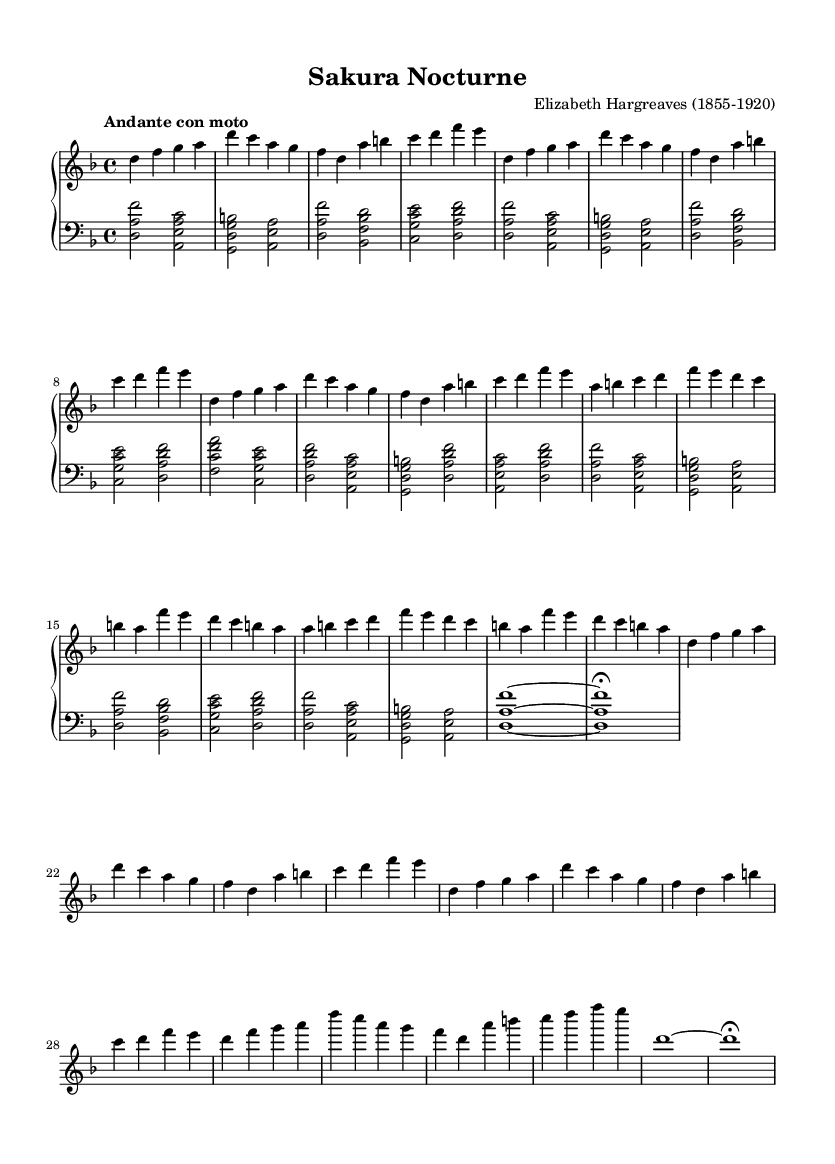What is the key signature of this music? The key signature is D minor, indicated by one flat (B flat) in the key signature line at the beginning of the staff. This is derived from the "global" context in the provided code.
Answer: D minor What is the time signature of this piece? The time signature is 4/4, shown at the beginning of the music. This indicates that there are four beats in each measure, and the quarter note gets one beat.
Answer: 4/4 What is the tempo marking for this piece? The tempo marking is "Andante con moto," which implies a moderately slow tempo with some movement. This is also detailed in the "global" context of the code.
Answer: Andante con moto What is the highest note in the right hand during section A? The highest note in the right hand during section A is A, found in the first measure of section A where the right hand plays A above the staff.
Answer: A How many measures are in the piece? The piece consists of 27 measures total; this can be determined by counting the measures in each section as defined in the right-hand and left-hand parts in the code.
Answer: 27 What is the chord of the left hand in the introduction first measure? The chord in the left hand during the first measure of the introduction is a D major chord (D, A, F#), which is identified by looking at the notes indicated in that measure.
Answer: D major How many sections are there in this composition? The composition has four sections (A, B, A', Coda), as identified in the code through the labeling of each section, reflecting the structure of the piece.
Answer: Four 